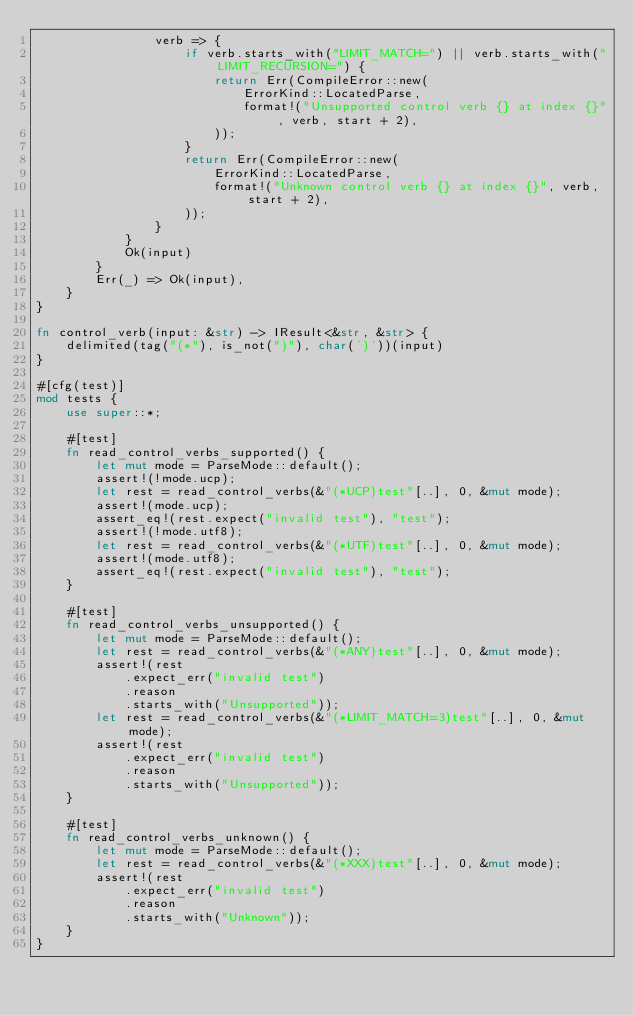<code> <loc_0><loc_0><loc_500><loc_500><_Rust_>                verb => {
                    if verb.starts_with("LIMIT_MATCH=") || verb.starts_with("LIMIT_RECURSION=") {
                        return Err(CompileError::new(
                            ErrorKind::LocatedParse,
                            format!("Unsupported control verb {} at index {}", verb, start + 2),
                        ));
                    }
                    return Err(CompileError::new(
                        ErrorKind::LocatedParse,
                        format!("Unknown control verb {} at index {}", verb, start + 2),
                    ));
                }
            }
            Ok(input)
        }
        Err(_) => Ok(input),
    }
}

fn control_verb(input: &str) -> IResult<&str, &str> {
    delimited(tag("(*"), is_not(")"), char(')'))(input)
}

#[cfg(test)]
mod tests {
    use super::*;

    #[test]
    fn read_control_verbs_supported() {
        let mut mode = ParseMode::default();
        assert!(!mode.ucp);
        let rest = read_control_verbs(&"(*UCP)test"[..], 0, &mut mode);
        assert!(mode.ucp);
        assert_eq!(rest.expect("invalid test"), "test");
        assert!(!mode.utf8);
        let rest = read_control_verbs(&"(*UTF)test"[..], 0, &mut mode);
        assert!(mode.utf8);
        assert_eq!(rest.expect("invalid test"), "test");
    }

    #[test]
    fn read_control_verbs_unsupported() {
        let mut mode = ParseMode::default();
        let rest = read_control_verbs(&"(*ANY)test"[..], 0, &mut mode);
        assert!(rest
            .expect_err("invalid test")
            .reason
            .starts_with("Unsupported"));
        let rest = read_control_verbs(&"(*LIMIT_MATCH=3)test"[..], 0, &mut mode);
        assert!(rest
            .expect_err("invalid test")
            .reason
            .starts_with("Unsupported"));
    }

    #[test]
    fn read_control_verbs_unknown() {
        let mut mode = ParseMode::default();
        let rest = read_control_verbs(&"(*XXX)test"[..], 0, &mut mode);
        assert!(rest
            .expect_err("invalid test")
            .reason
            .starts_with("Unknown"));
    }
}
</code> 